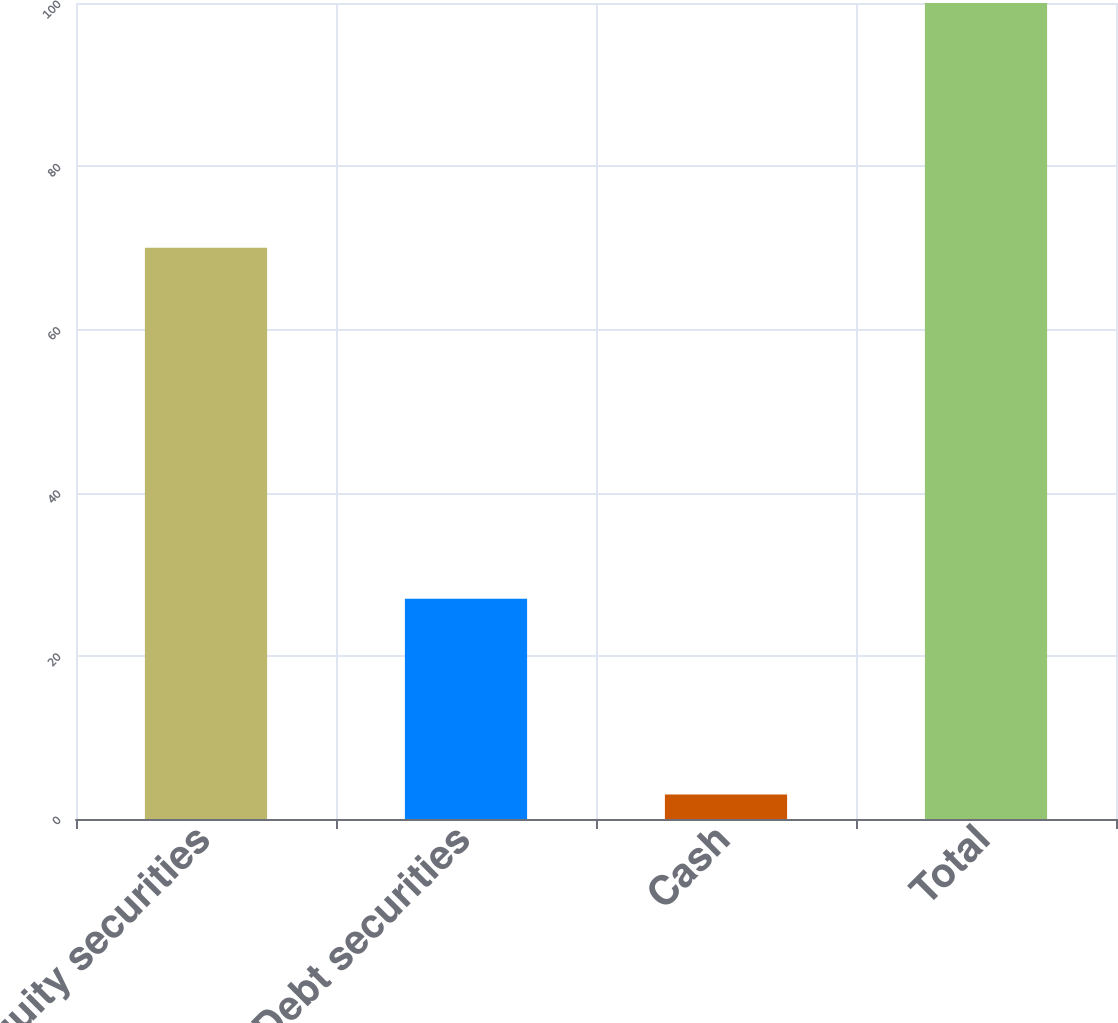<chart> <loc_0><loc_0><loc_500><loc_500><bar_chart><fcel>Equity securities<fcel>Debt securities<fcel>Cash<fcel>Total<nl><fcel>70<fcel>27<fcel>3<fcel>100<nl></chart> 